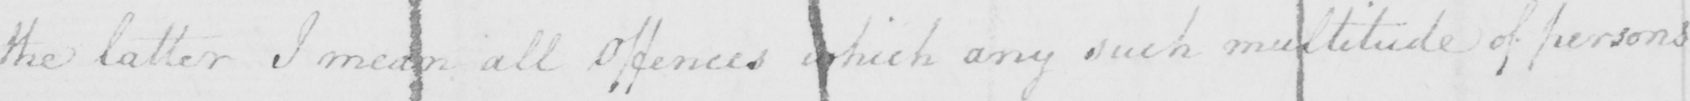Can you tell me what this handwritten text says? the latter I mean all offences which any such multitude of persons 